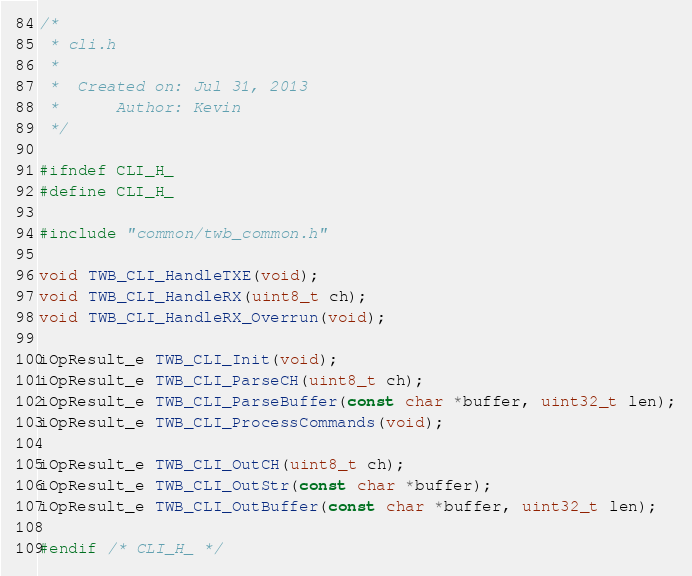<code> <loc_0><loc_0><loc_500><loc_500><_C_>/*
 * cli.h
 *
 *  Created on: Jul 31, 2013
 *      Author: Kevin
 */

#ifndef CLI_H_
#define CLI_H_

#include "common/twb_common.h"

void TWB_CLI_HandleTXE(void);
void TWB_CLI_HandleRX(uint8_t ch);
void TWB_CLI_HandleRX_Overrun(void);

iOpResult_e TWB_CLI_Init(void);
iOpResult_e TWB_CLI_ParseCH(uint8_t ch);
iOpResult_e TWB_CLI_ParseBuffer(const char *buffer, uint32_t len);
iOpResult_e TWB_CLI_ProcessCommands(void);

iOpResult_e TWB_CLI_OutCH(uint8_t ch);
iOpResult_e TWB_CLI_OutStr(const char *buffer);
iOpResult_e TWB_CLI_OutBuffer(const char *buffer, uint32_t len);

#endif /* CLI_H_ */
</code> 